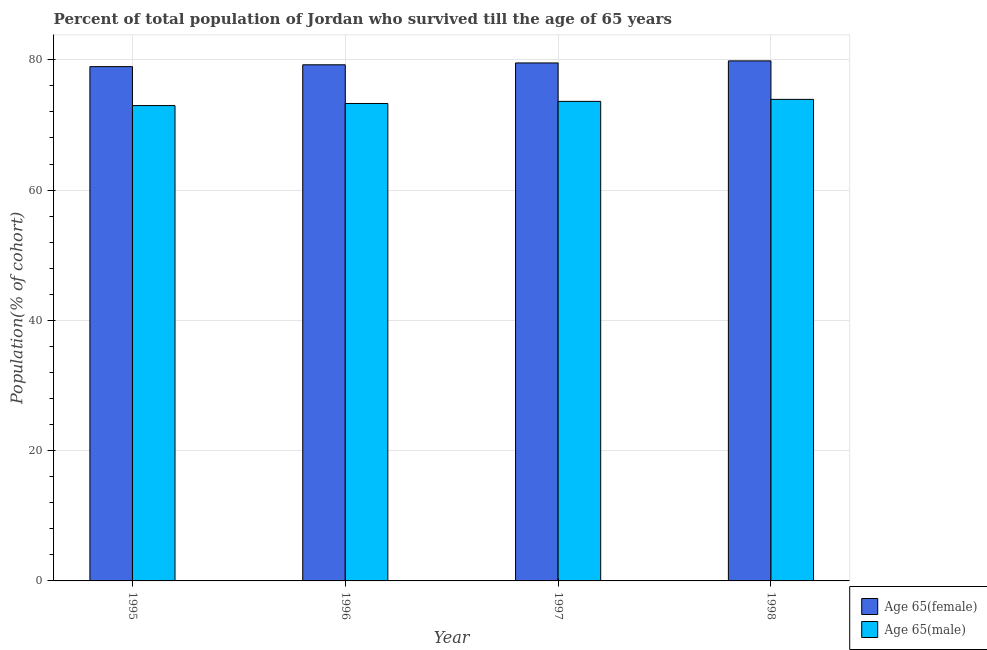In how many cases, is the number of bars for a given year not equal to the number of legend labels?
Your answer should be very brief. 0. What is the percentage of female population who survived till age of 65 in 1995?
Offer a very short reply. 78.95. Across all years, what is the maximum percentage of female population who survived till age of 65?
Your answer should be compact. 79.84. Across all years, what is the minimum percentage of male population who survived till age of 65?
Make the answer very short. 72.97. In which year was the percentage of male population who survived till age of 65 maximum?
Your answer should be very brief. 1998. In which year was the percentage of male population who survived till age of 65 minimum?
Provide a succinct answer. 1995. What is the total percentage of male population who survived till age of 65 in the graph?
Your answer should be very brief. 293.82. What is the difference between the percentage of male population who survived till age of 65 in 1997 and that in 1998?
Provide a short and direct response. -0.31. What is the difference between the percentage of female population who survived till age of 65 in 1996 and the percentage of male population who survived till age of 65 in 1997?
Provide a short and direct response. -0.28. What is the average percentage of male population who survived till age of 65 per year?
Give a very brief answer. 73.45. In the year 1995, what is the difference between the percentage of male population who survived till age of 65 and percentage of female population who survived till age of 65?
Offer a very short reply. 0. What is the ratio of the percentage of male population who survived till age of 65 in 1996 to that in 1997?
Provide a short and direct response. 1. Is the percentage of male population who survived till age of 65 in 1996 less than that in 1997?
Offer a very short reply. Yes. What is the difference between the highest and the second highest percentage of male population who survived till age of 65?
Your response must be concise. 0.31. What is the difference between the highest and the lowest percentage of male population who survived till age of 65?
Your answer should be compact. 0.95. What does the 1st bar from the left in 1996 represents?
Your answer should be compact. Age 65(female). What does the 1st bar from the right in 1998 represents?
Keep it short and to the point. Age 65(male). How many years are there in the graph?
Provide a short and direct response. 4. Are the values on the major ticks of Y-axis written in scientific E-notation?
Provide a succinct answer. No. Does the graph contain grids?
Ensure brevity in your answer.  Yes. How many legend labels are there?
Your answer should be compact. 2. What is the title of the graph?
Provide a short and direct response. Percent of total population of Jordan who survived till the age of 65 years. What is the label or title of the Y-axis?
Ensure brevity in your answer.  Population(% of cohort). What is the Population(% of cohort) of Age 65(female) in 1995?
Keep it short and to the point. 78.95. What is the Population(% of cohort) in Age 65(male) in 1995?
Ensure brevity in your answer.  72.97. What is the Population(% of cohort) in Age 65(female) in 1996?
Your response must be concise. 79.24. What is the Population(% of cohort) in Age 65(male) in 1996?
Provide a succinct answer. 73.3. What is the Population(% of cohort) of Age 65(female) in 1997?
Your answer should be very brief. 79.52. What is the Population(% of cohort) in Age 65(male) in 1997?
Offer a terse response. 73.62. What is the Population(% of cohort) in Age 65(female) in 1998?
Offer a terse response. 79.84. What is the Population(% of cohort) of Age 65(male) in 1998?
Your response must be concise. 73.93. Across all years, what is the maximum Population(% of cohort) of Age 65(female)?
Ensure brevity in your answer.  79.84. Across all years, what is the maximum Population(% of cohort) of Age 65(male)?
Provide a short and direct response. 73.93. Across all years, what is the minimum Population(% of cohort) of Age 65(female)?
Your response must be concise. 78.95. Across all years, what is the minimum Population(% of cohort) of Age 65(male)?
Offer a very short reply. 72.97. What is the total Population(% of cohort) of Age 65(female) in the graph?
Offer a very short reply. 317.55. What is the total Population(% of cohort) of Age 65(male) in the graph?
Offer a terse response. 293.82. What is the difference between the Population(% of cohort) in Age 65(female) in 1995 and that in 1996?
Ensure brevity in your answer.  -0.28. What is the difference between the Population(% of cohort) in Age 65(male) in 1995 and that in 1996?
Provide a succinct answer. -0.32. What is the difference between the Population(% of cohort) of Age 65(female) in 1995 and that in 1997?
Give a very brief answer. -0.57. What is the difference between the Population(% of cohort) of Age 65(male) in 1995 and that in 1997?
Offer a terse response. -0.65. What is the difference between the Population(% of cohort) of Age 65(female) in 1995 and that in 1998?
Your response must be concise. -0.88. What is the difference between the Population(% of cohort) in Age 65(male) in 1995 and that in 1998?
Keep it short and to the point. -0.95. What is the difference between the Population(% of cohort) in Age 65(female) in 1996 and that in 1997?
Give a very brief answer. -0.28. What is the difference between the Population(% of cohort) in Age 65(male) in 1996 and that in 1997?
Offer a terse response. -0.32. What is the difference between the Population(% of cohort) of Age 65(female) in 1996 and that in 1998?
Offer a terse response. -0.6. What is the difference between the Population(% of cohort) in Age 65(male) in 1996 and that in 1998?
Make the answer very short. -0.63. What is the difference between the Population(% of cohort) of Age 65(female) in 1997 and that in 1998?
Make the answer very short. -0.32. What is the difference between the Population(% of cohort) of Age 65(male) in 1997 and that in 1998?
Make the answer very short. -0.31. What is the difference between the Population(% of cohort) in Age 65(female) in 1995 and the Population(% of cohort) in Age 65(male) in 1996?
Provide a short and direct response. 5.66. What is the difference between the Population(% of cohort) of Age 65(female) in 1995 and the Population(% of cohort) of Age 65(male) in 1997?
Offer a very short reply. 5.33. What is the difference between the Population(% of cohort) of Age 65(female) in 1995 and the Population(% of cohort) of Age 65(male) in 1998?
Give a very brief answer. 5.03. What is the difference between the Population(% of cohort) of Age 65(female) in 1996 and the Population(% of cohort) of Age 65(male) in 1997?
Provide a short and direct response. 5.62. What is the difference between the Population(% of cohort) in Age 65(female) in 1996 and the Population(% of cohort) in Age 65(male) in 1998?
Your response must be concise. 5.31. What is the difference between the Population(% of cohort) of Age 65(female) in 1997 and the Population(% of cohort) of Age 65(male) in 1998?
Keep it short and to the point. 5.59. What is the average Population(% of cohort) of Age 65(female) per year?
Your answer should be very brief. 79.39. What is the average Population(% of cohort) of Age 65(male) per year?
Offer a terse response. 73.45. In the year 1995, what is the difference between the Population(% of cohort) of Age 65(female) and Population(% of cohort) of Age 65(male)?
Offer a very short reply. 5.98. In the year 1996, what is the difference between the Population(% of cohort) of Age 65(female) and Population(% of cohort) of Age 65(male)?
Provide a short and direct response. 5.94. In the year 1997, what is the difference between the Population(% of cohort) in Age 65(female) and Population(% of cohort) in Age 65(male)?
Ensure brevity in your answer.  5.9. In the year 1998, what is the difference between the Population(% of cohort) of Age 65(female) and Population(% of cohort) of Age 65(male)?
Keep it short and to the point. 5.91. What is the ratio of the Population(% of cohort) in Age 65(male) in 1995 to that in 1996?
Your answer should be very brief. 1. What is the ratio of the Population(% of cohort) in Age 65(female) in 1995 to that in 1998?
Offer a terse response. 0.99. What is the ratio of the Population(% of cohort) in Age 65(male) in 1995 to that in 1998?
Keep it short and to the point. 0.99. What is the ratio of the Population(% of cohort) of Age 65(female) in 1996 to that in 1997?
Your answer should be very brief. 1. What is the ratio of the Population(% of cohort) of Age 65(male) in 1996 to that in 1997?
Offer a terse response. 1. What is the ratio of the Population(% of cohort) of Age 65(female) in 1996 to that in 1998?
Your response must be concise. 0.99. What is the difference between the highest and the second highest Population(% of cohort) of Age 65(female)?
Give a very brief answer. 0.32. What is the difference between the highest and the second highest Population(% of cohort) of Age 65(male)?
Your answer should be very brief. 0.31. What is the difference between the highest and the lowest Population(% of cohort) in Age 65(female)?
Your response must be concise. 0.88. What is the difference between the highest and the lowest Population(% of cohort) in Age 65(male)?
Your response must be concise. 0.95. 